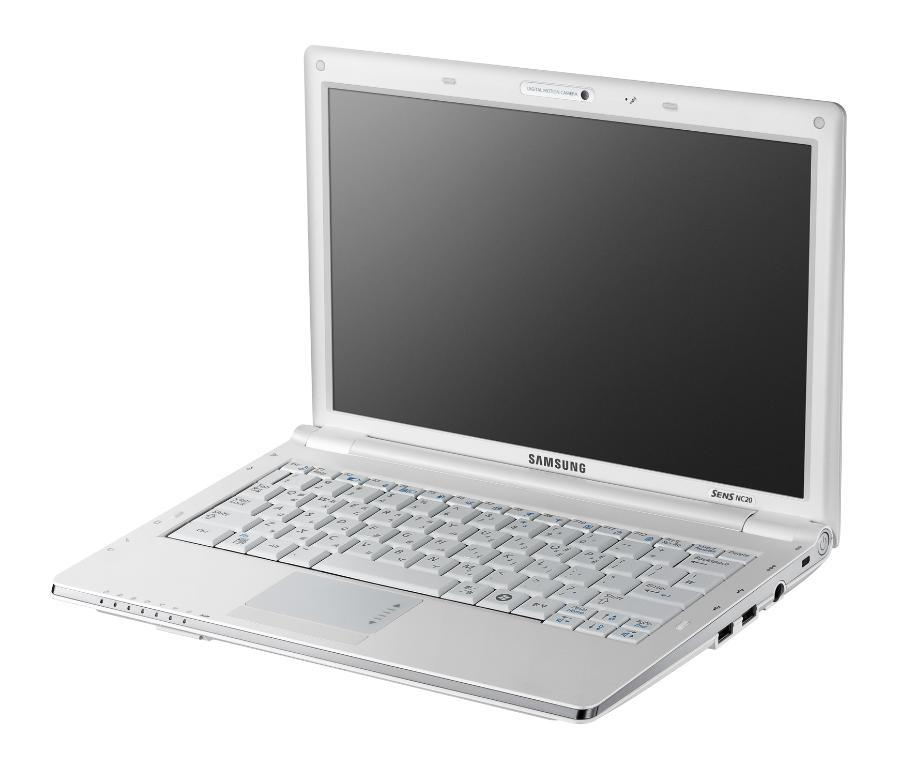<image>
Provide a brief description of the given image. White Samsung laptop with the words SENSNC20 on it. 